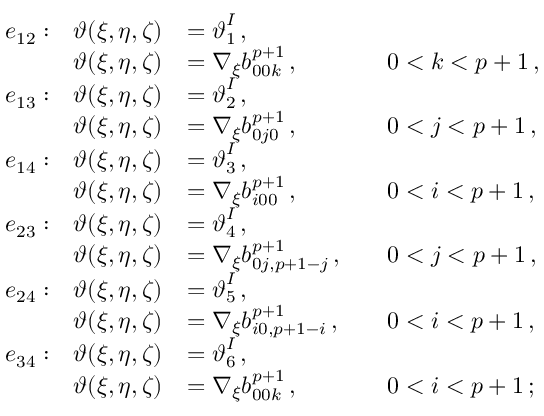Convert formula to latex. <formula><loc_0><loc_0><loc_500><loc_500>\begin{array} { r l r l r l } & { e _ { 1 2 } \colon } & { \vartheta ( \xi , \eta , \zeta ) } & { = \vartheta _ { 1 } ^ { I } \, , } \\ & { \vartheta ( \xi , \eta , \zeta ) } & { = \nabla _ { \xi } b _ { 0 0 k } ^ { p + 1 } \, , } & & { 0 < k < p + 1 \, , } \\ & { e _ { 1 3 } \colon } & { \vartheta ( \xi , \eta , \zeta ) } & { = \vartheta _ { 2 } ^ { I } \, , } \\ & { \vartheta ( \xi , \eta , \zeta ) } & { = \nabla _ { \xi } b _ { 0 j 0 } ^ { p + 1 } \, , } & & { 0 < j < p + 1 \, , } \\ & { e _ { 1 4 } \colon } & { \vartheta ( \xi , \eta , \zeta ) } & { = \vartheta _ { 3 } ^ { I } \, , } \\ & { \vartheta ( \xi , \eta , \zeta ) } & { = \nabla _ { \xi } b _ { i 0 0 } ^ { p + 1 } \, , } & & { 0 < i < p + 1 \, , } \\ & { e _ { 2 3 } \colon } & { \vartheta ( \xi , \eta , \zeta ) } & { = \vartheta _ { 4 } ^ { I } \, , } \\ & { \vartheta ( \xi , \eta , \zeta ) } & { = \nabla _ { \xi } b _ { 0 j , p + 1 - j } ^ { p + 1 } \, , } & & { 0 < j < p + 1 \, , } \\ & { e _ { 2 4 } \colon } & { \vartheta ( \xi , \eta , \zeta ) } & { = \vartheta _ { 5 } ^ { I } \, , } \\ & { \vartheta ( \xi , \eta , \zeta ) } & { = \nabla _ { \xi } b _ { i 0 , p + 1 - i } ^ { p + 1 } \, , } & & { 0 < i < p + 1 \, , } \\ & { e _ { 3 4 } \colon } & { \vartheta ( \xi , \eta , \zeta ) } & { = \vartheta _ { 6 } ^ { I } \, , } \\ & { \vartheta ( \xi , \eta , \zeta ) } & { = \nabla _ { \xi } b _ { 0 0 k } ^ { p + 1 } \, , } & & { 0 < i < p + 1 \, ; } \end{array}</formula> 